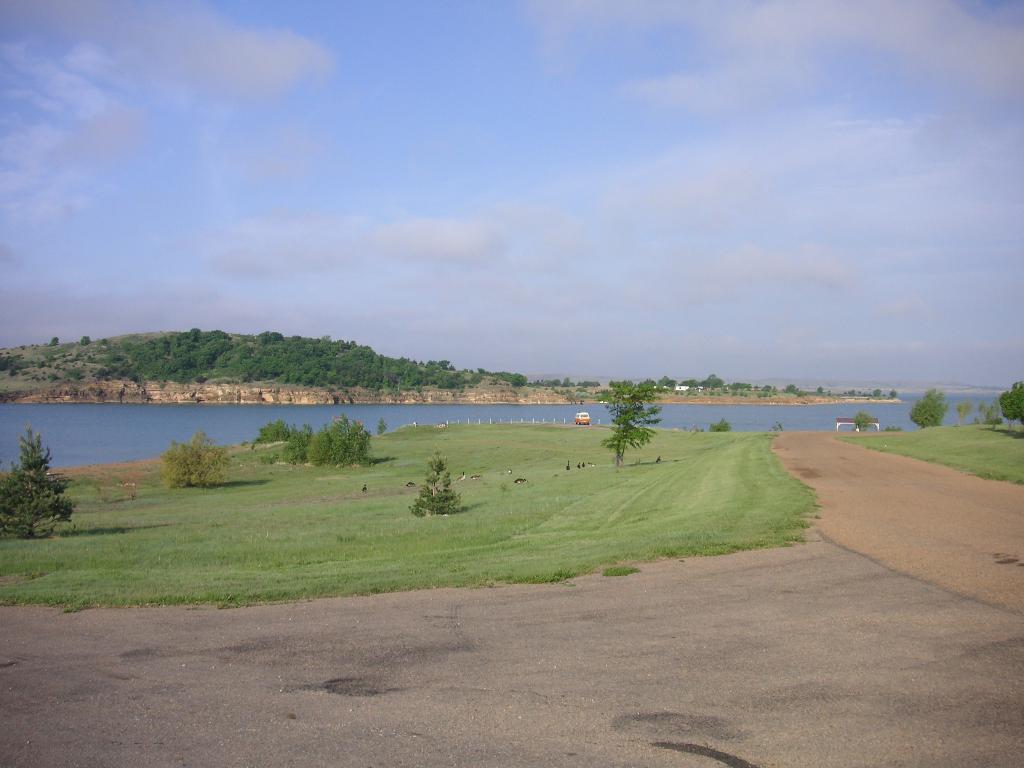Could you give a brief overview of what you see in this image? In this image there is a vehicle and birds on the grass, there are stone pillars, water, few trees, a house, mountains and some clouds in the sky. 